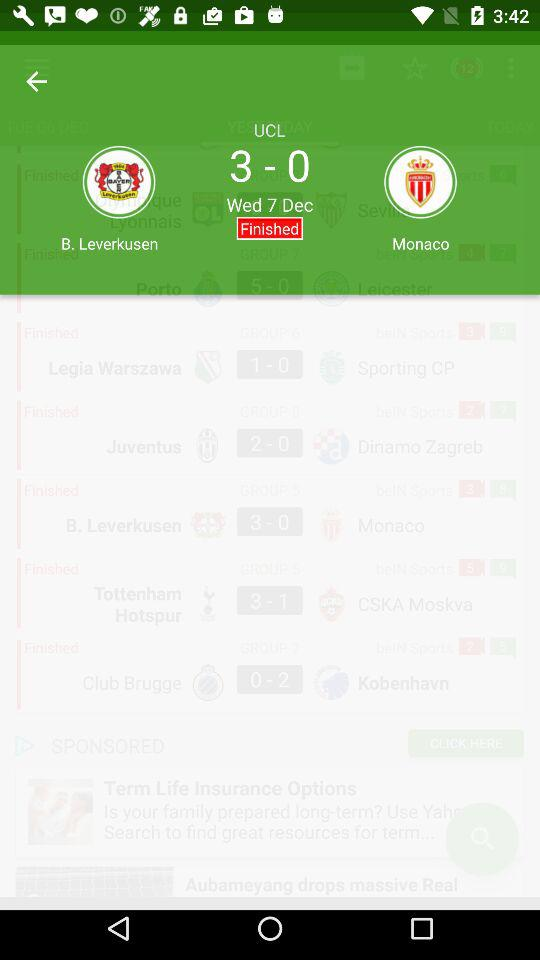What is the score between the two teams? The score between the two teams is 3-0. 